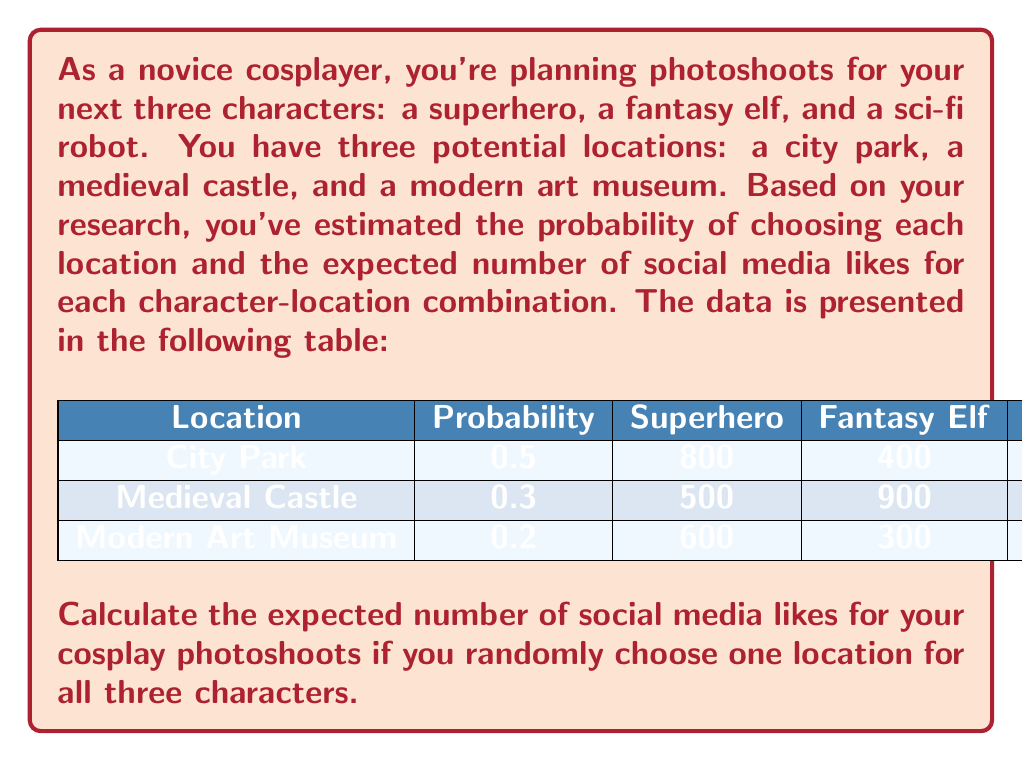Could you help me with this problem? To solve this problem, we need to calculate the expected value of likes for each location and then sum these values weighted by their probabilities. Let's break it down step-by-step:

1) For each location, calculate the total likes for all three characters:

   City Park: $800 + 400 + 300 = 1500$ likes
   Medieval Castle: $500 + 900 + 400 = 1800$ likes
   Modern Art Museum: $600 + 300 + 1000 = 1900$ likes

2) Now, we need to multiply each total by its probability and sum the results:

   City Park: $1500 \times 0.5 = 750$
   Medieval Castle: $1800 \times 0.3 = 540$
   Modern Art Museum: $1900 \times 0.2 = 380$

3) The expected value is the sum of these products:

   $E(\text{likes}) = 750 + 540 + 380 = 1670$

Therefore, the expected number of social media likes for your cosplay photoshoots if you randomly choose one location for all three characters is 1670.

This can also be expressed using the expected value formula:

$$E(\text{likes}) = \sum_{i=1}^{3} p_i \times (\sum_{j=1}^{3} l_{ij})$$

Where $p_i$ is the probability of choosing location $i$, and $l_{ij}$ is the number of likes for character $j$ at location $i$.
Answer: 1670 likes 